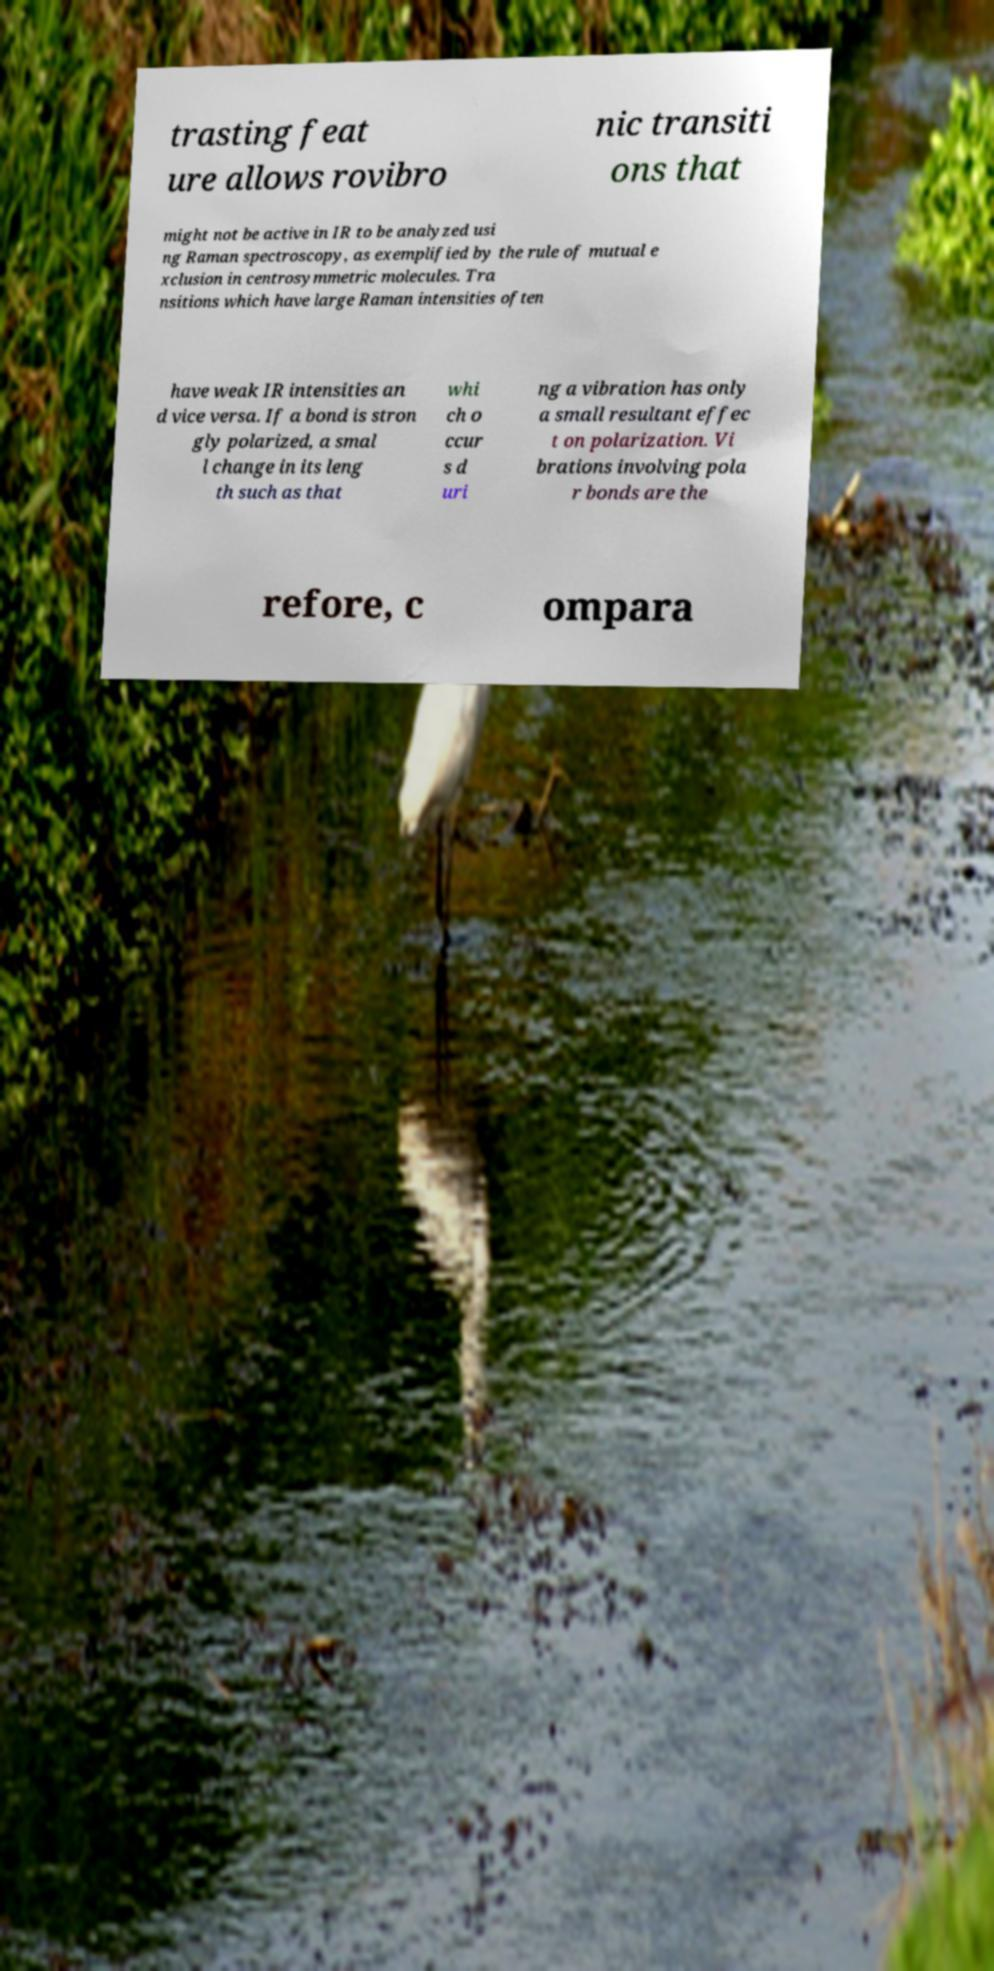Could you assist in decoding the text presented in this image and type it out clearly? trasting feat ure allows rovibro nic transiti ons that might not be active in IR to be analyzed usi ng Raman spectroscopy, as exemplified by the rule of mutual e xclusion in centrosymmetric molecules. Tra nsitions which have large Raman intensities often have weak IR intensities an d vice versa. If a bond is stron gly polarized, a smal l change in its leng th such as that whi ch o ccur s d uri ng a vibration has only a small resultant effec t on polarization. Vi brations involving pola r bonds are the refore, c ompara 